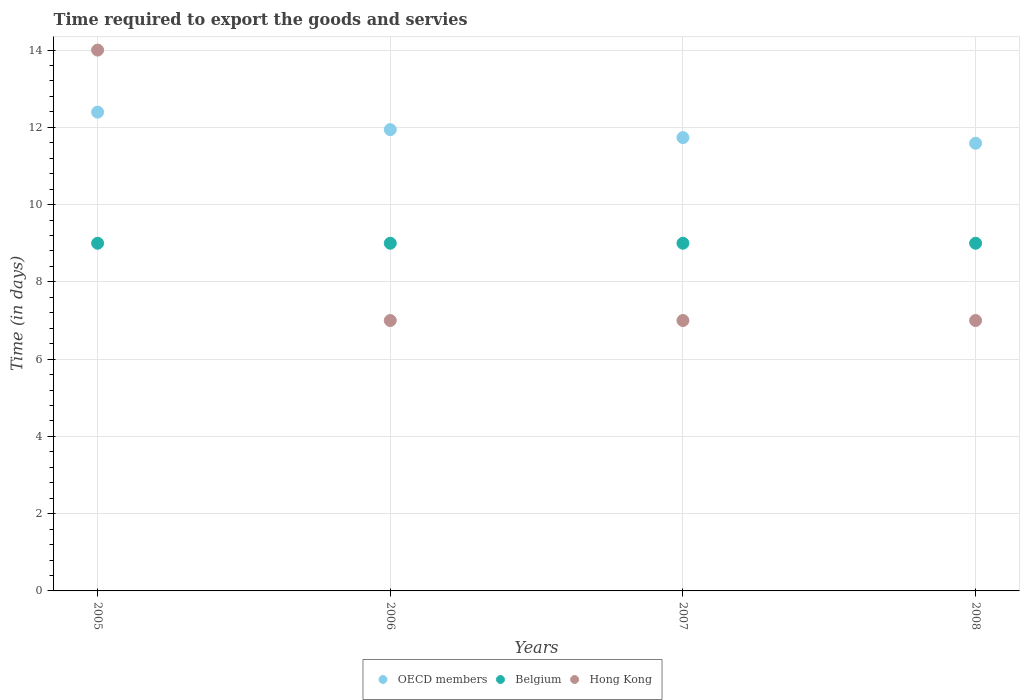How many different coloured dotlines are there?
Make the answer very short. 3. Is the number of dotlines equal to the number of legend labels?
Keep it short and to the point. Yes. What is the number of days required to export the goods and services in Hong Kong in 2005?
Your answer should be compact. 14. Across all years, what is the maximum number of days required to export the goods and services in Belgium?
Keep it short and to the point. 9. Across all years, what is the minimum number of days required to export the goods and services in Belgium?
Ensure brevity in your answer.  9. In which year was the number of days required to export the goods and services in Hong Kong maximum?
Offer a very short reply. 2005. What is the total number of days required to export the goods and services in Belgium in the graph?
Provide a succinct answer. 36. What is the difference between the number of days required to export the goods and services in Belgium in 2006 and that in 2007?
Keep it short and to the point. 0. What is the difference between the number of days required to export the goods and services in OECD members in 2006 and the number of days required to export the goods and services in Hong Kong in 2008?
Provide a succinct answer. 4.94. What is the average number of days required to export the goods and services in OECD members per year?
Make the answer very short. 11.91. In the year 2006, what is the difference between the number of days required to export the goods and services in Hong Kong and number of days required to export the goods and services in OECD members?
Give a very brief answer. -4.94. In how many years, is the number of days required to export the goods and services in OECD members greater than 7.2 days?
Offer a terse response. 4. What is the difference between the highest and the second highest number of days required to export the goods and services in Hong Kong?
Your answer should be very brief. 7. What is the difference between the highest and the lowest number of days required to export the goods and services in OECD members?
Offer a very short reply. 0.81. Is the sum of the number of days required to export the goods and services in OECD members in 2007 and 2008 greater than the maximum number of days required to export the goods and services in Hong Kong across all years?
Ensure brevity in your answer.  Yes. Is the number of days required to export the goods and services in Hong Kong strictly greater than the number of days required to export the goods and services in Belgium over the years?
Your answer should be compact. No. Is the number of days required to export the goods and services in Belgium strictly less than the number of days required to export the goods and services in OECD members over the years?
Your answer should be very brief. Yes. How many years are there in the graph?
Keep it short and to the point. 4. What is the difference between two consecutive major ticks on the Y-axis?
Give a very brief answer. 2. Are the values on the major ticks of Y-axis written in scientific E-notation?
Ensure brevity in your answer.  No. Does the graph contain grids?
Provide a succinct answer. Yes. How many legend labels are there?
Your response must be concise. 3. How are the legend labels stacked?
Ensure brevity in your answer.  Horizontal. What is the title of the graph?
Keep it short and to the point. Time required to export the goods and servies. Does "United Arab Emirates" appear as one of the legend labels in the graph?
Keep it short and to the point. No. What is the label or title of the X-axis?
Make the answer very short. Years. What is the label or title of the Y-axis?
Give a very brief answer. Time (in days). What is the Time (in days) in OECD members in 2005?
Your answer should be compact. 12.39. What is the Time (in days) in Belgium in 2005?
Offer a terse response. 9. What is the Time (in days) in Hong Kong in 2005?
Make the answer very short. 14. What is the Time (in days) in OECD members in 2006?
Your answer should be compact. 11.94. What is the Time (in days) in Hong Kong in 2006?
Your response must be concise. 7. What is the Time (in days) of OECD members in 2007?
Ensure brevity in your answer.  11.74. What is the Time (in days) of Belgium in 2007?
Provide a short and direct response. 9. What is the Time (in days) of Hong Kong in 2007?
Offer a very short reply. 7. What is the Time (in days) in OECD members in 2008?
Your answer should be very brief. 11.59. What is the Time (in days) of Belgium in 2008?
Your answer should be compact. 9. Across all years, what is the maximum Time (in days) in OECD members?
Your answer should be compact. 12.39. Across all years, what is the maximum Time (in days) of Belgium?
Your answer should be compact. 9. Across all years, what is the minimum Time (in days) of OECD members?
Give a very brief answer. 11.59. Across all years, what is the minimum Time (in days) in Belgium?
Give a very brief answer. 9. Across all years, what is the minimum Time (in days) of Hong Kong?
Provide a short and direct response. 7. What is the total Time (in days) in OECD members in the graph?
Provide a succinct answer. 47.66. What is the total Time (in days) in Belgium in the graph?
Your answer should be very brief. 36. What is the total Time (in days) of Hong Kong in the graph?
Ensure brevity in your answer.  35. What is the difference between the Time (in days) of OECD members in 2005 and that in 2006?
Provide a short and direct response. 0.45. What is the difference between the Time (in days) in OECD members in 2005 and that in 2007?
Give a very brief answer. 0.66. What is the difference between the Time (in days) of OECD members in 2005 and that in 2008?
Offer a terse response. 0.81. What is the difference between the Time (in days) of OECD members in 2006 and that in 2007?
Ensure brevity in your answer.  0.21. What is the difference between the Time (in days) in Belgium in 2006 and that in 2007?
Your response must be concise. 0. What is the difference between the Time (in days) of Hong Kong in 2006 and that in 2007?
Make the answer very short. 0. What is the difference between the Time (in days) in OECD members in 2006 and that in 2008?
Offer a very short reply. 0.35. What is the difference between the Time (in days) of Belgium in 2006 and that in 2008?
Keep it short and to the point. 0. What is the difference between the Time (in days) in OECD members in 2007 and that in 2008?
Ensure brevity in your answer.  0.15. What is the difference between the Time (in days) of OECD members in 2005 and the Time (in days) of Belgium in 2006?
Make the answer very short. 3.39. What is the difference between the Time (in days) in OECD members in 2005 and the Time (in days) in Hong Kong in 2006?
Give a very brief answer. 5.39. What is the difference between the Time (in days) of OECD members in 2005 and the Time (in days) of Belgium in 2007?
Your response must be concise. 3.39. What is the difference between the Time (in days) in OECD members in 2005 and the Time (in days) in Hong Kong in 2007?
Ensure brevity in your answer.  5.39. What is the difference between the Time (in days) in OECD members in 2005 and the Time (in days) in Belgium in 2008?
Provide a succinct answer. 3.39. What is the difference between the Time (in days) of OECD members in 2005 and the Time (in days) of Hong Kong in 2008?
Offer a terse response. 5.39. What is the difference between the Time (in days) of OECD members in 2006 and the Time (in days) of Belgium in 2007?
Keep it short and to the point. 2.94. What is the difference between the Time (in days) in OECD members in 2006 and the Time (in days) in Hong Kong in 2007?
Your response must be concise. 4.94. What is the difference between the Time (in days) of OECD members in 2006 and the Time (in days) of Belgium in 2008?
Give a very brief answer. 2.94. What is the difference between the Time (in days) of OECD members in 2006 and the Time (in days) of Hong Kong in 2008?
Your answer should be compact. 4.94. What is the difference between the Time (in days) in OECD members in 2007 and the Time (in days) in Belgium in 2008?
Keep it short and to the point. 2.74. What is the difference between the Time (in days) in OECD members in 2007 and the Time (in days) in Hong Kong in 2008?
Offer a terse response. 4.74. What is the difference between the Time (in days) of Belgium in 2007 and the Time (in days) of Hong Kong in 2008?
Your response must be concise. 2. What is the average Time (in days) in OECD members per year?
Your answer should be compact. 11.91. What is the average Time (in days) of Hong Kong per year?
Offer a very short reply. 8.75. In the year 2005, what is the difference between the Time (in days) in OECD members and Time (in days) in Belgium?
Make the answer very short. 3.39. In the year 2005, what is the difference between the Time (in days) of OECD members and Time (in days) of Hong Kong?
Provide a short and direct response. -1.61. In the year 2005, what is the difference between the Time (in days) in Belgium and Time (in days) in Hong Kong?
Make the answer very short. -5. In the year 2006, what is the difference between the Time (in days) in OECD members and Time (in days) in Belgium?
Your response must be concise. 2.94. In the year 2006, what is the difference between the Time (in days) of OECD members and Time (in days) of Hong Kong?
Your response must be concise. 4.94. In the year 2007, what is the difference between the Time (in days) in OECD members and Time (in days) in Belgium?
Your response must be concise. 2.74. In the year 2007, what is the difference between the Time (in days) in OECD members and Time (in days) in Hong Kong?
Provide a short and direct response. 4.74. In the year 2008, what is the difference between the Time (in days) of OECD members and Time (in days) of Belgium?
Provide a succinct answer. 2.59. In the year 2008, what is the difference between the Time (in days) of OECD members and Time (in days) of Hong Kong?
Offer a very short reply. 4.59. In the year 2008, what is the difference between the Time (in days) of Belgium and Time (in days) of Hong Kong?
Keep it short and to the point. 2. What is the ratio of the Time (in days) of OECD members in 2005 to that in 2006?
Your answer should be very brief. 1.04. What is the ratio of the Time (in days) of Belgium in 2005 to that in 2006?
Provide a short and direct response. 1. What is the ratio of the Time (in days) of OECD members in 2005 to that in 2007?
Your response must be concise. 1.06. What is the ratio of the Time (in days) in OECD members in 2005 to that in 2008?
Keep it short and to the point. 1.07. What is the ratio of the Time (in days) in Belgium in 2005 to that in 2008?
Your answer should be compact. 1. What is the ratio of the Time (in days) of OECD members in 2006 to that in 2007?
Make the answer very short. 1.02. What is the ratio of the Time (in days) in Hong Kong in 2006 to that in 2007?
Provide a succinct answer. 1. What is the ratio of the Time (in days) in OECD members in 2006 to that in 2008?
Give a very brief answer. 1.03. What is the ratio of the Time (in days) in Belgium in 2006 to that in 2008?
Offer a terse response. 1. What is the ratio of the Time (in days) in Hong Kong in 2006 to that in 2008?
Provide a succinct answer. 1. What is the ratio of the Time (in days) of OECD members in 2007 to that in 2008?
Make the answer very short. 1.01. What is the difference between the highest and the second highest Time (in days) of OECD members?
Your answer should be compact. 0.45. What is the difference between the highest and the second highest Time (in days) of Belgium?
Provide a short and direct response. 0. What is the difference between the highest and the lowest Time (in days) in OECD members?
Offer a very short reply. 0.81. What is the difference between the highest and the lowest Time (in days) of Belgium?
Make the answer very short. 0. What is the difference between the highest and the lowest Time (in days) in Hong Kong?
Your answer should be compact. 7. 